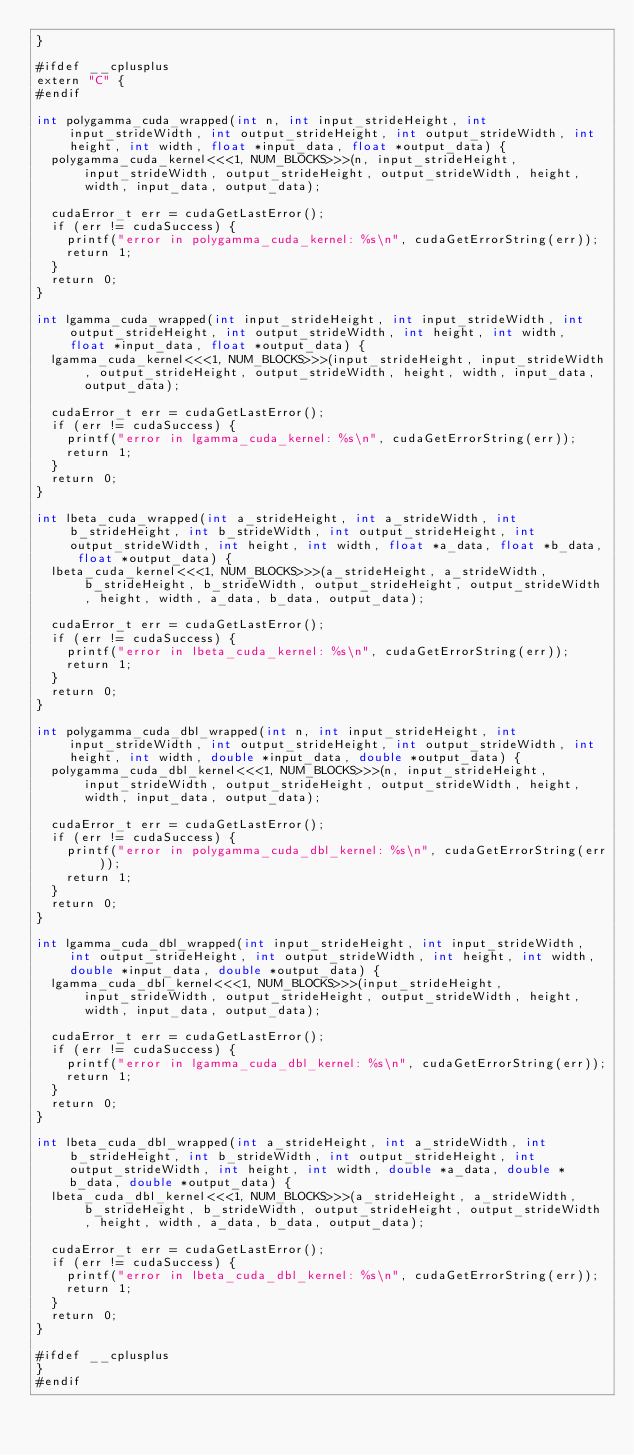<code> <loc_0><loc_0><loc_500><loc_500><_Cuda_>}

#ifdef __cplusplus
extern "C" {
#endif

int polygamma_cuda_wrapped(int n, int input_strideHeight, int input_strideWidth, int output_strideHeight, int output_strideWidth, int height, int width, float *input_data, float *output_data) {
  polygamma_cuda_kernel<<<1, NUM_BLOCKS>>>(n, input_strideHeight, input_strideWidth, output_strideHeight, output_strideWidth, height, width, input_data, output_data);

  cudaError_t err = cudaGetLastError();
  if (err != cudaSuccess) {
    printf("error in polygamma_cuda_kernel: %s\n", cudaGetErrorString(err));
    return 1;
  }
  return 0;
}

int lgamma_cuda_wrapped(int input_strideHeight, int input_strideWidth, int output_strideHeight, int output_strideWidth, int height, int width, float *input_data, float *output_data) {
  lgamma_cuda_kernel<<<1, NUM_BLOCKS>>>(input_strideHeight, input_strideWidth, output_strideHeight, output_strideWidth, height, width, input_data, output_data);

  cudaError_t err = cudaGetLastError();
  if (err != cudaSuccess) {
    printf("error in lgamma_cuda_kernel: %s\n", cudaGetErrorString(err));
    return 1;
  }
  return 0;
}

int lbeta_cuda_wrapped(int a_strideHeight, int a_strideWidth, int b_strideHeight, int b_strideWidth, int output_strideHeight, int output_strideWidth, int height, int width, float *a_data, float *b_data, float *output_data) {
  lbeta_cuda_kernel<<<1, NUM_BLOCKS>>>(a_strideHeight, a_strideWidth, b_strideHeight, b_strideWidth, output_strideHeight, output_strideWidth, height, width, a_data, b_data, output_data);

  cudaError_t err = cudaGetLastError();
  if (err != cudaSuccess) {
    printf("error in lbeta_cuda_kernel: %s\n", cudaGetErrorString(err));
    return 1;
  }
  return 0;
}

int polygamma_cuda_dbl_wrapped(int n, int input_strideHeight, int input_strideWidth, int output_strideHeight, int output_strideWidth, int height, int width, double *input_data, double *output_data) {
  polygamma_cuda_dbl_kernel<<<1, NUM_BLOCKS>>>(n, input_strideHeight, input_strideWidth, output_strideHeight, output_strideWidth, height, width, input_data, output_data);

  cudaError_t err = cudaGetLastError();
  if (err != cudaSuccess) {
    printf("error in polygamma_cuda_dbl_kernel: %s\n", cudaGetErrorString(err));
    return 1;
  }
  return 0;
}

int lgamma_cuda_dbl_wrapped(int input_strideHeight, int input_strideWidth, int output_strideHeight, int output_strideWidth, int height, int width, double *input_data, double *output_data) {
  lgamma_cuda_dbl_kernel<<<1, NUM_BLOCKS>>>(input_strideHeight, input_strideWidth, output_strideHeight, output_strideWidth, height, width, input_data, output_data);

  cudaError_t err = cudaGetLastError();
  if (err != cudaSuccess) {
    printf("error in lgamma_cuda_dbl_kernel: %s\n", cudaGetErrorString(err));
    return 1;
  }
  return 0;
}

int lbeta_cuda_dbl_wrapped(int a_strideHeight, int a_strideWidth, int b_strideHeight, int b_strideWidth, int output_strideHeight, int output_strideWidth, int height, int width, double *a_data, double *b_data, double *output_data) {
  lbeta_cuda_dbl_kernel<<<1, NUM_BLOCKS>>>(a_strideHeight, a_strideWidth, b_strideHeight, b_strideWidth, output_strideHeight, output_strideWidth, height, width, a_data, b_data, output_data);

  cudaError_t err = cudaGetLastError();
  if (err != cudaSuccess) {
    printf("error in lbeta_cuda_dbl_kernel: %s\n", cudaGetErrorString(err));
    return 1;
  }
  return 0;
}

#ifdef __cplusplus
}
#endif
</code> 